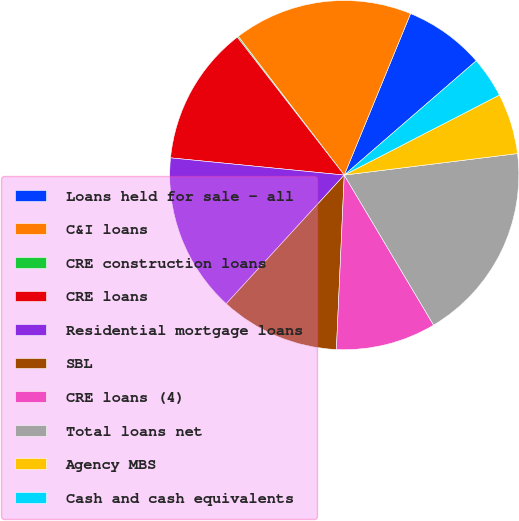<chart> <loc_0><loc_0><loc_500><loc_500><pie_chart><fcel>Loans held for sale - all<fcel>C&I loans<fcel>CRE construction loans<fcel>CRE loans<fcel>Residential mortgage loans<fcel>SBL<fcel>CRE loans (4)<fcel>Total loans net<fcel>Agency MBS<fcel>Cash and cash equivalents<nl><fcel>7.44%<fcel>16.59%<fcel>0.11%<fcel>12.93%<fcel>14.76%<fcel>11.1%<fcel>9.27%<fcel>18.42%<fcel>5.61%<fcel>3.78%<nl></chart> 